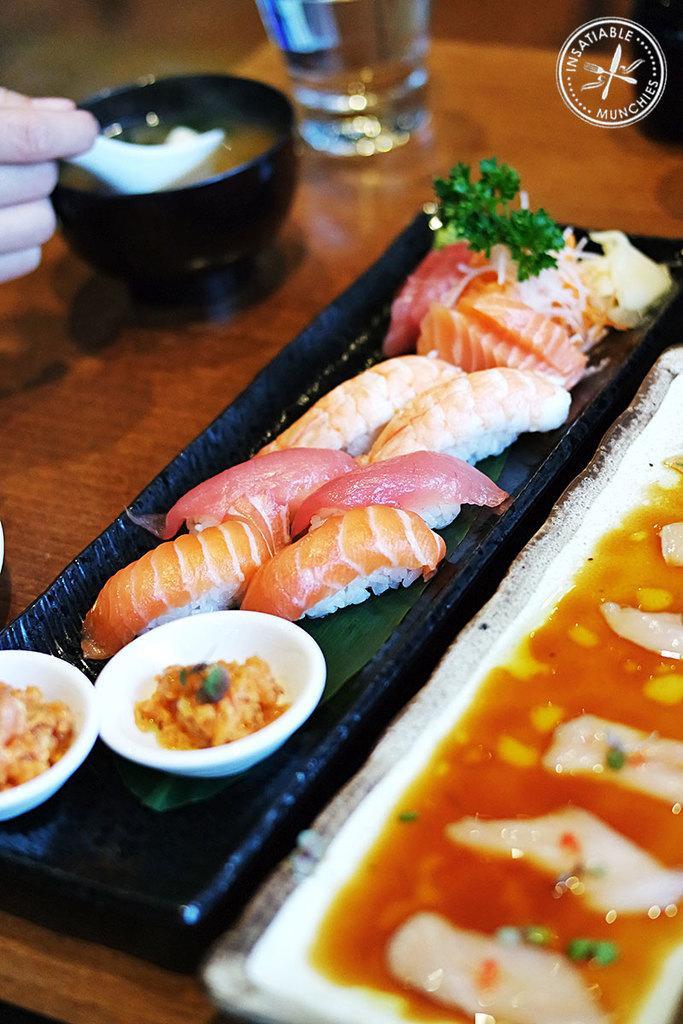Could you give a brief overview of what you see in this image? In this picture we can see food in the plates and bowls, and also we can find a glass on the table. 